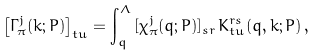<formula> <loc_0><loc_0><loc_500><loc_500>\left [ \Gamma _ { \pi } ^ { j } ( k ; P ) \right ] _ { t u } = \int ^ { \Lambda } _ { q } \, [ \chi _ { \pi } ^ { j } ( q ; P ) ] _ { s r } \, K ^ { r s } _ { t u } ( q , k ; P ) \, ,</formula> 